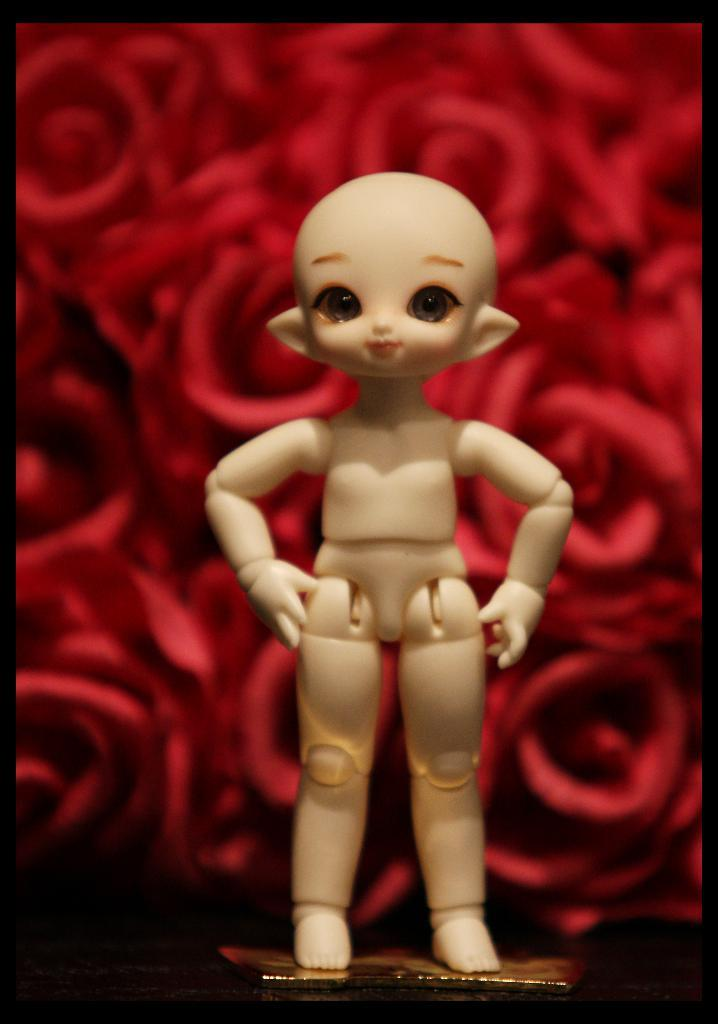What is the main subject in the center of the image? There is a doll in the center of the image. What can be seen in the background of the image? There is a screen in the background of the image. What advice does the queen give to the expert in the image? There is no queen or expert present in the image; it only features a doll and a screen in the background. 